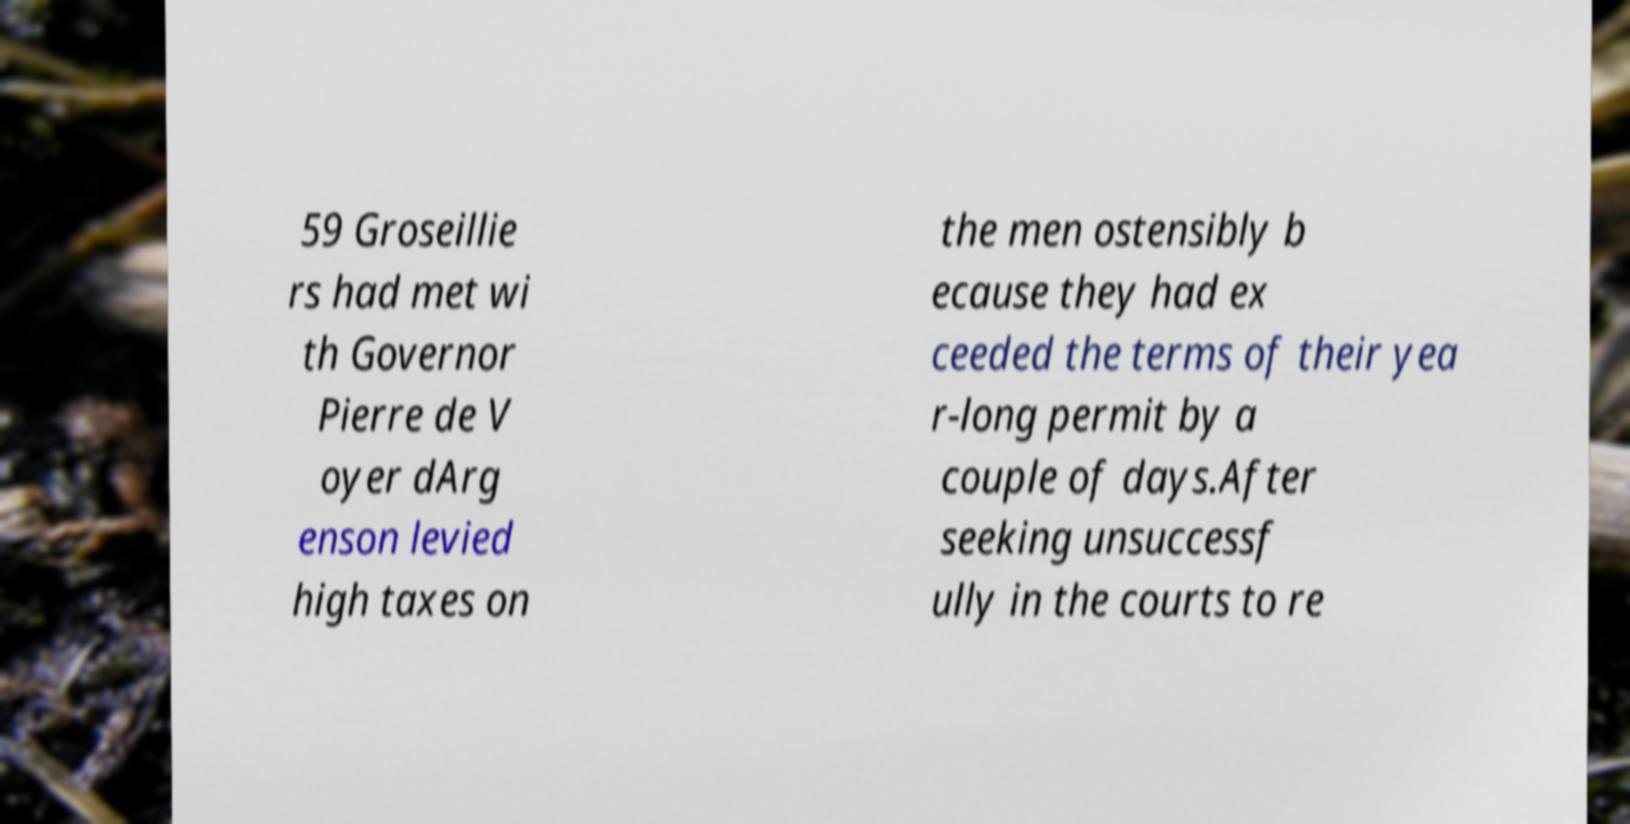There's text embedded in this image that I need extracted. Can you transcribe it verbatim? 59 Groseillie rs had met wi th Governor Pierre de V oyer dArg enson levied high taxes on the men ostensibly b ecause they had ex ceeded the terms of their yea r-long permit by a couple of days.After seeking unsuccessf ully in the courts to re 